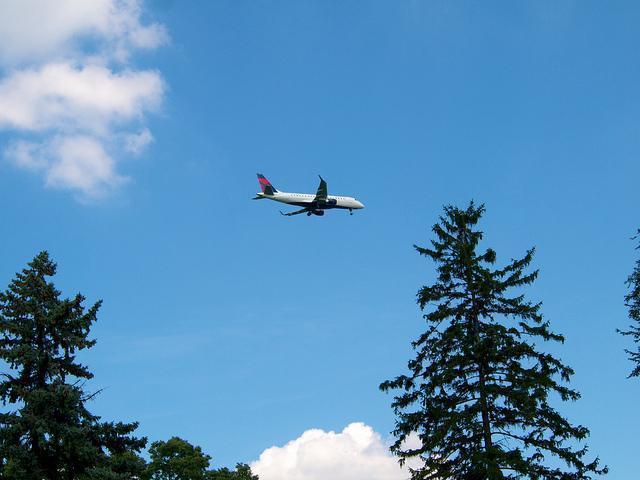How many planes are in the sky?
Give a very brief answer. 1. 